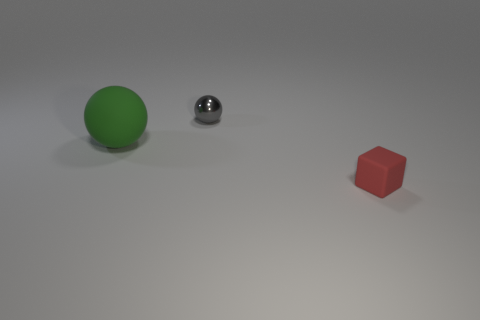Add 1 red cubes. How many objects exist? 4 Subtract all cyan spheres. Subtract all purple blocks. How many spheres are left? 2 Subtract all spheres. How many objects are left? 1 Subtract all small red cylinders. Subtract all red matte cubes. How many objects are left? 2 Add 1 tiny things. How many tiny things are left? 3 Add 3 large matte spheres. How many large matte spheres exist? 4 Subtract 0 gray cylinders. How many objects are left? 3 